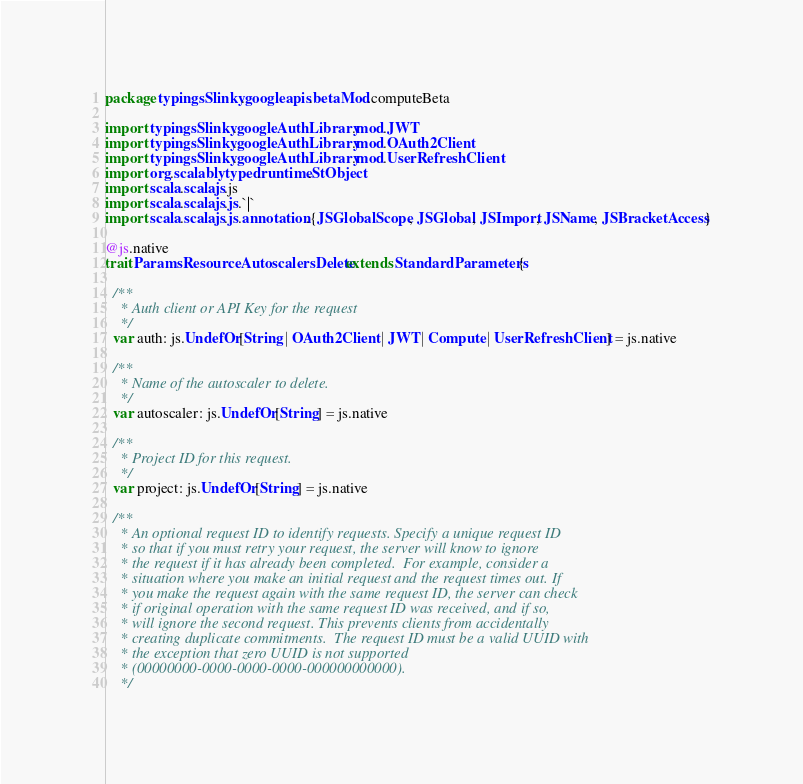<code> <loc_0><loc_0><loc_500><loc_500><_Scala_>package typingsSlinky.googleapis.betaMod.computeBeta

import typingsSlinky.googleAuthLibrary.mod.JWT
import typingsSlinky.googleAuthLibrary.mod.OAuth2Client
import typingsSlinky.googleAuthLibrary.mod.UserRefreshClient
import org.scalablytyped.runtime.StObject
import scala.scalajs.js
import scala.scalajs.js.`|`
import scala.scalajs.js.annotation.{JSGlobalScope, JSGlobal, JSImport, JSName, JSBracketAccess}

@js.native
trait ParamsResourceAutoscalersDelete extends StandardParameters {
  
  /**
    * Auth client or API Key for the request
    */
  var auth: js.UndefOr[String | OAuth2Client | JWT | Compute | UserRefreshClient] = js.native
  
  /**
    * Name of the autoscaler to delete.
    */
  var autoscaler: js.UndefOr[String] = js.native
  
  /**
    * Project ID for this request.
    */
  var project: js.UndefOr[String] = js.native
  
  /**
    * An optional request ID to identify requests. Specify a unique request ID
    * so that if you must retry your request, the server will know to ignore
    * the request if it has already been completed.  For example, consider a
    * situation where you make an initial request and the request times out. If
    * you make the request again with the same request ID, the server can check
    * if original operation with the same request ID was received, and if so,
    * will ignore the second request. This prevents clients from accidentally
    * creating duplicate commitments.  The request ID must be a valid UUID with
    * the exception that zero UUID is not supported
    * (00000000-0000-0000-0000-000000000000).
    */</code> 